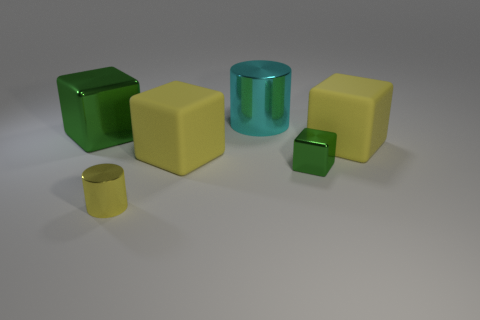There is a matte object that is right of the small shiny block; is its color the same as the tiny cylinder?
Ensure brevity in your answer.  Yes. What color is the other metal object that is the same shape as the small green metallic object?
Your answer should be compact. Green. What is the yellow cylinder that is to the left of the large cyan thing made of?
Your answer should be compact. Metal. The small metal block has what color?
Offer a terse response. Green. Do the shiny thing on the right side of the cyan object and the tiny yellow thing have the same size?
Give a very brief answer. Yes. There is a large yellow object that is on the right side of the cyan metal thing to the right of the yellow rubber object that is on the left side of the cyan metallic cylinder; what is it made of?
Give a very brief answer. Rubber. There is a object left of the tiny yellow cylinder; is it the same color as the tiny shiny object behind the tiny yellow metal thing?
Give a very brief answer. Yes. There is a green block behind the matte cube right of the cyan cylinder; what is its material?
Provide a succinct answer. Metal. What is the color of the block that is the same size as the yellow metallic cylinder?
Your answer should be compact. Green. There is a big green shiny object; is it the same shape as the green metallic thing on the right side of the big cyan metallic thing?
Provide a succinct answer. Yes. 